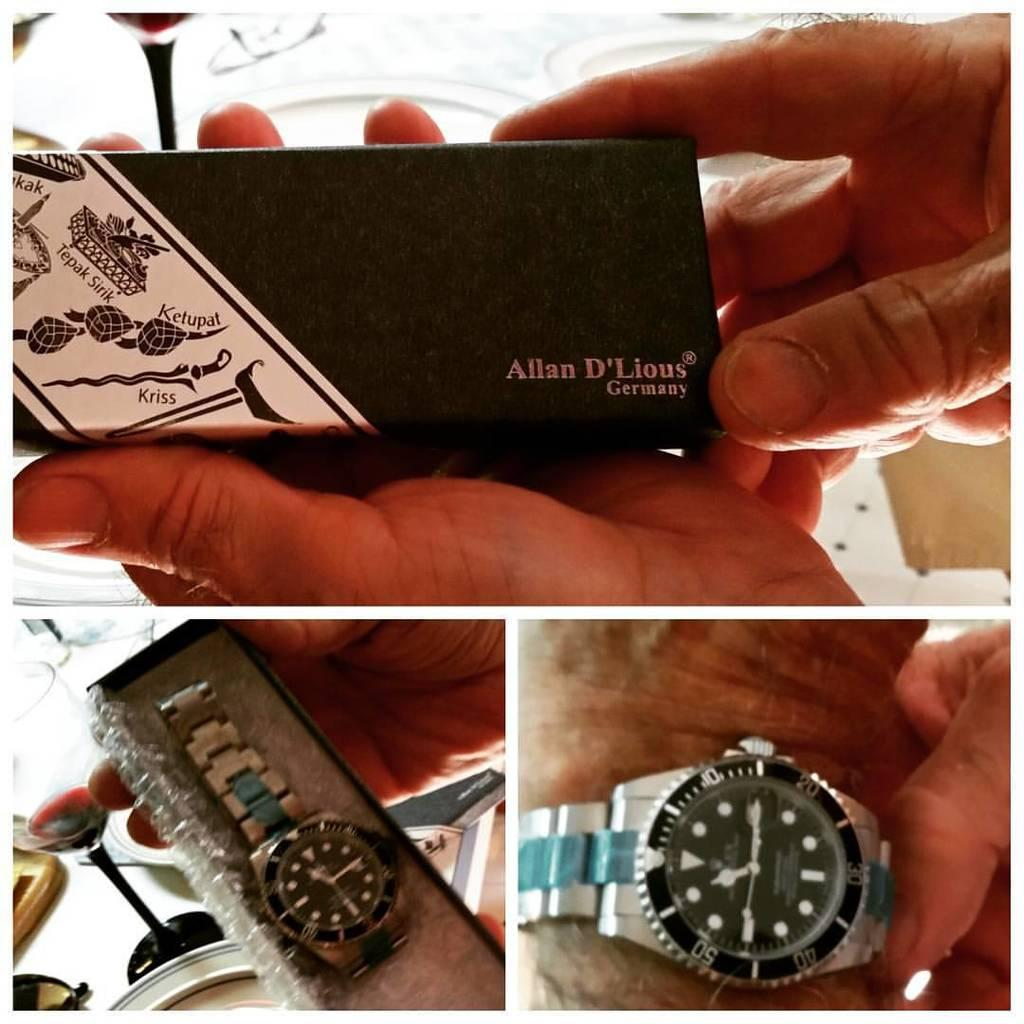Provide a one-sentence caption for the provided image. An Allan D'Lious brand wristwatch, shown in its packaging and on a man's arm. 